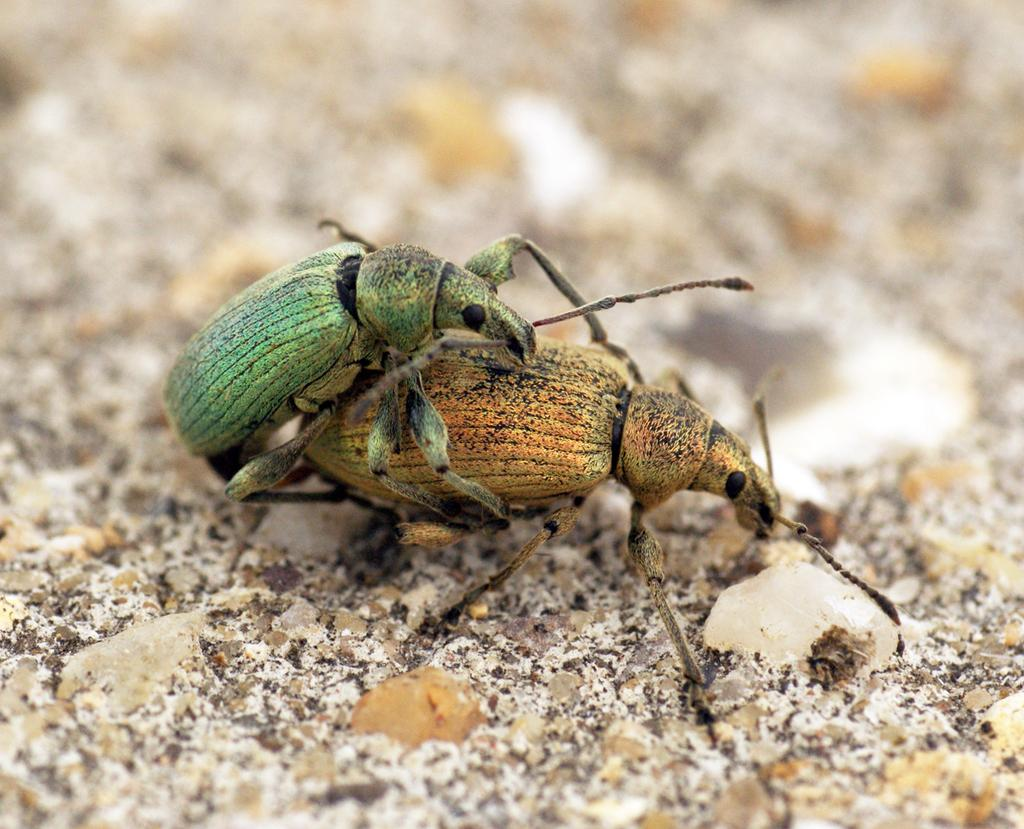What type of creatures can be seen in the image? There are insects in the image. What is the background or surface in the image? There is a surface visible in the image. Can you describe the top part of the image? The top of the image has a blurry view. What time does the clock show in the image? There is no clock present in the image. Can you describe the zebra in the image? There is no zebra present in the image. 